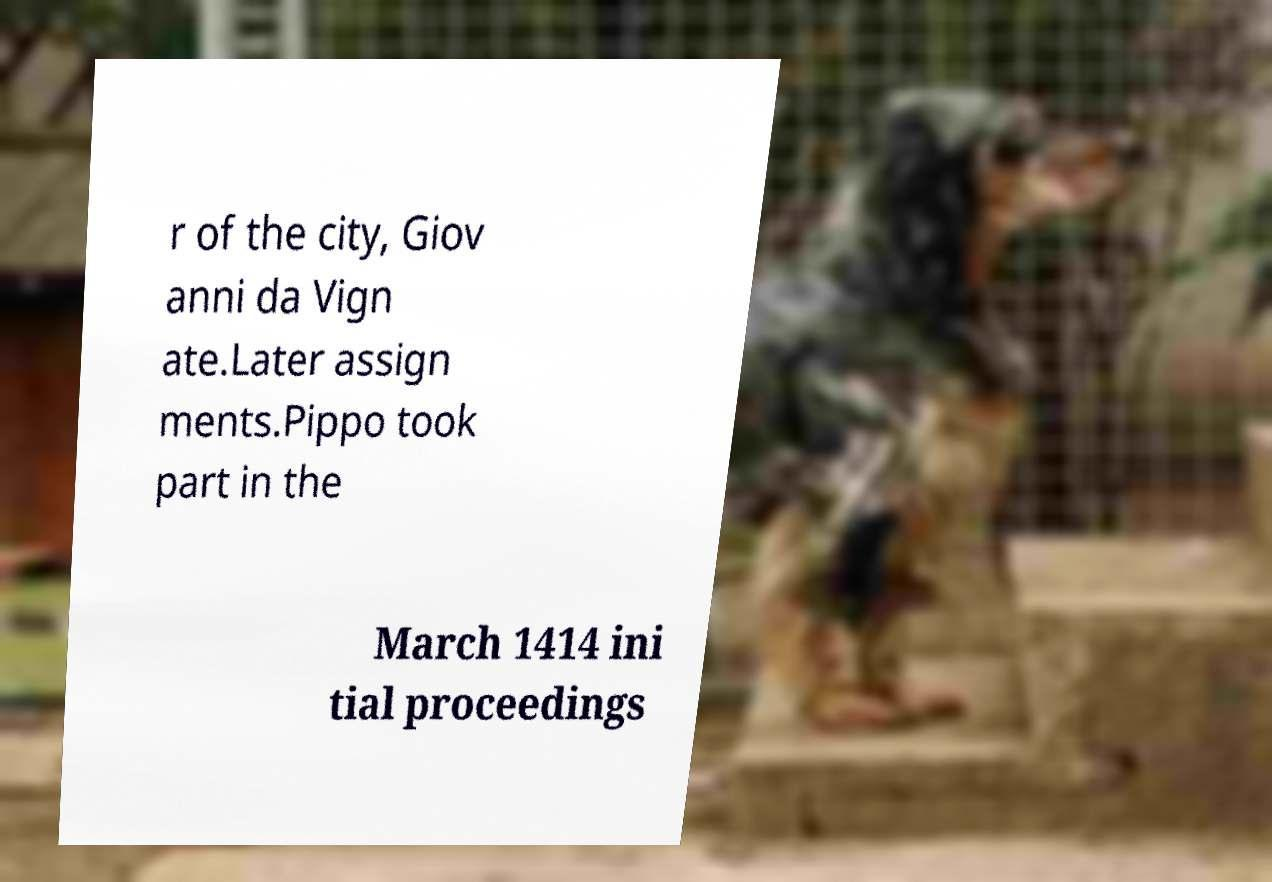I need the written content from this picture converted into text. Can you do that? r of the city, Giov anni da Vign ate.Later assign ments.Pippo took part in the March 1414 ini tial proceedings 